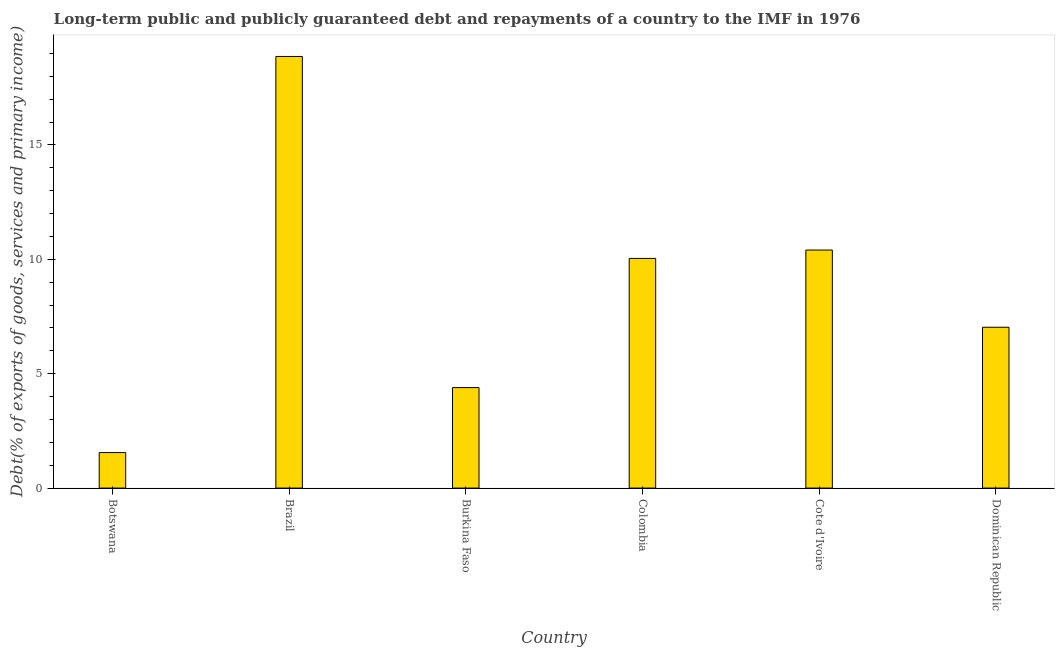What is the title of the graph?
Keep it short and to the point. Long-term public and publicly guaranteed debt and repayments of a country to the IMF in 1976. What is the label or title of the X-axis?
Offer a very short reply. Country. What is the label or title of the Y-axis?
Offer a very short reply. Debt(% of exports of goods, services and primary income). What is the debt service in Cote d'Ivoire?
Give a very brief answer. 10.4. Across all countries, what is the maximum debt service?
Your response must be concise. 18.86. Across all countries, what is the minimum debt service?
Keep it short and to the point. 1.55. In which country was the debt service minimum?
Provide a succinct answer. Botswana. What is the sum of the debt service?
Offer a terse response. 52.28. What is the difference between the debt service in Colombia and Cote d'Ivoire?
Provide a short and direct response. -0.37. What is the average debt service per country?
Ensure brevity in your answer.  8.71. What is the median debt service?
Make the answer very short. 8.53. What is the ratio of the debt service in Burkina Faso to that in Cote d'Ivoire?
Make the answer very short. 0.42. What is the difference between the highest and the second highest debt service?
Your answer should be compact. 8.46. Is the sum of the debt service in Botswana and Colombia greater than the maximum debt service across all countries?
Your answer should be compact. No. What is the difference between the highest and the lowest debt service?
Give a very brief answer. 17.31. How many bars are there?
Make the answer very short. 6. How many countries are there in the graph?
Provide a short and direct response. 6. What is the difference between two consecutive major ticks on the Y-axis?
Provide a succinct answer. 5. What is the Debt(% of exports of goods, services and primary income) in Botswana?
Offer a very short reply. 1.55. What is the Debt(% of exports of goods, services and primary income) of Brazil?
Keep it short and to the point. 18.86. What is the Debt(% of exports of goods, services and primary income) in Burkina Faso?
Your response must be concise. 4.39. What is the Debt(% of exports of goods, services and primary income) in Colombia?
Keep it short and to the point. 10.04. What is the Debt(% of exports of goods, services and primary income) of Cote d'Ivoire?
Ensure brevity in your answer.  10.4. What is the Debt(% of exports of goods, services and primary income) of Dominican Republic?
Your answer should be compact. 7.03. What is the difference between the Debt(% of exports of goods, services and primary income) in Botswana and Brazil?
Offer a very short reply. -17.31. What is the difference between the Debt(% of exports of goods, services and primary income) in Botswana and Burkina Faso?
Your answer should be very brief. -2.84. What is the difference between the Debt(% of exports of goods, services and primary income) in Botswana and Colombia?
Provide a succinct answer. -8.49. What is the difference between the Debt(% of exports of goods, services and primary income) in Botswana and Cote d'Ivoire?
Ensure brevity in your answer.  -8.85. What is the difference between the Debt(% of exports of goods, services and primary income) in Botswana and Dominican Republic?
Your answer should be very brief. -5.48. What is the difference between the Debt(% of exports of goods, services and primary income) in Brazil and Burkina Faso?
Provide a short and direct response. 14.47. What is the difference between the Debt(% of exports of goods, services and primary income) in Brazil and Colombia?
Offer a very short reply. 8.83. What is the difference between the Debt(% of exports of goods, services and primary income) in Brazil and Cote d'Ivoire?
Provide a succinct answer. 8.46. What is the difference between the Debt(% of exports of goods, services and primary income) in Brazil and Dominican Republic?
Provide a succinct answer. 11.83. What is the difference between the Debt(% of exports of goods, services and primary income) in Burkina Faso and Colombia?
Your answer should be very brief. -5.65. What is the difference between the Debt(% of exports of goods, services and primary income) in Burkina Faso and Cote d'Ivoire?
Keep it short and to the point. -6.01. What is the difference between the Debt(% of exports of goods, services and primary income) in Burkina Faso and Dominican Republic?
Your answer should be compact. -2.64. What is the difference between the Debt(% of exports of goods, services and primary income) in Colombia and Cote d'Ivoire?
Your answer should be compact. -0.37. What is the difference between the Debt(% of exports of goods, services and primary income) in Colombia and Dominican Republic?
Provide a short and direct response. 3.01. What is the difference between the Debt(% of exports of goods, services and primary income) in Cote d'Ivoire and Dominican Republic?
Make the answer very short. 3.37. What is the ratio of the Debt(% of exports of goods, services and primary income) in Botswana to that in Brazil?
Keep it short and to the point. 0.08. What is the ratio of the Debt(% of exports of goods, services and primary income) in Botswana to that in Burkina Faso?
Ensure brevity in your answer.  0.35. What is the ratio of the Debt(% of exports of goods, services and primary income) in Botswana to that in Colombia?
Your response must be concise. 0.15. What is the ratio of the Debt(% of exports of goods, services and primary income) in Botswana to that in Cote d'Ivoire?
Provide a succinct answer. 0.15. What is the ratio of the Debt(% of exports of goods, services and primary income) in Botswana to that in Dominican Republic?
Offer a terse response. 0.22. What is the ratio of the Debt(% of exports of goods, services and primary income) in Brazil to that in Burkina Faso?
Keep it short and to the point. 4.29. What is the ratio of the Debt(% of exports of goods, services and primary income) in Brazil to that in Colombia?
Keep it short and to the point. 1.88. What is the ratio of the Debt(% of exports of goods, services and primary income) in Brazil to that in Cote d'Ivoire?
Provide a short and direct response. 1.81. What is the ratio of the Debt(% of exports of goods, services and primary income) in Brazil to that in Dominican Republic?
Offer a terse response. 2.68. What is the ratio of the Debt(% of exports of goods, services and primary income) in Burkina Faso to that in Colombia?
Your response must be concise. 0.44. What is the ratio of the Debt(% of exports of goods, services and primary income) in Burkina Faso to that in Cote d'Ivoire?
Offer a terse response. 0.42. What is the ratio of the Debt(% of exports of goods, services and primary income) in Colombia to that in Cote d'Ivoire?
Make the answer very short. 0.96. What is the ratio of the Debt(% of exports of goods, services and primary income) in Colombia to that in Dominican Republic?
Your answer should be very brief. 1.43. What is the ratio of the Debt(% of exports of goods, services and primary income) in Cote d'Ivoire to that in Dominican Republic?
Provide a short and direct response. 1.48. 